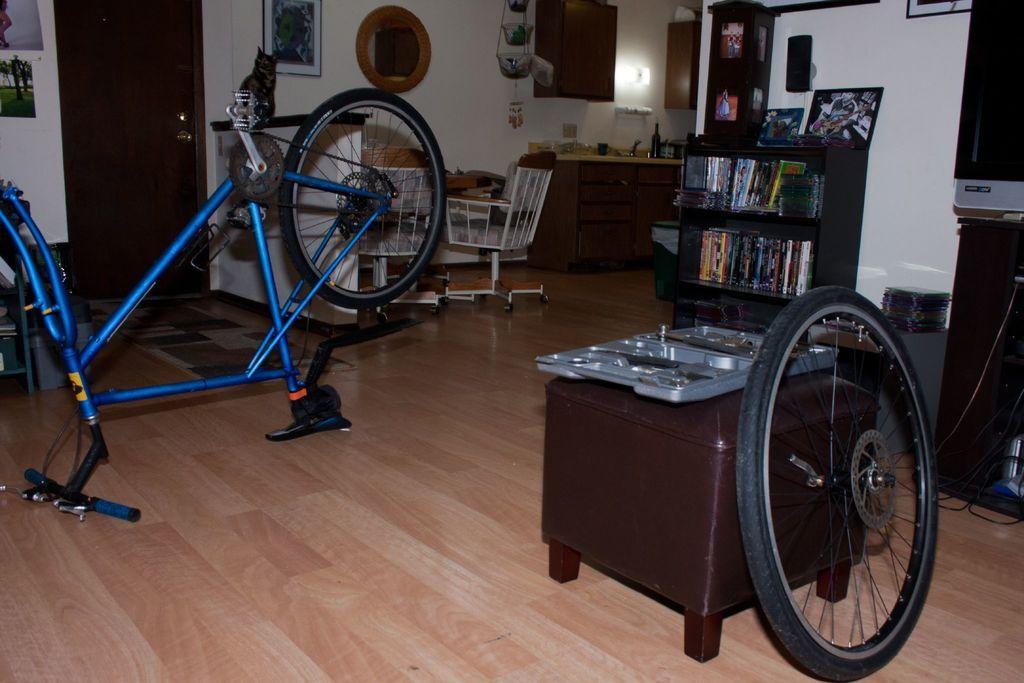Could you give a brief overview of what you see in this image? In this image I can see a bicycle which is blue in color on the floor, a brown colored couch, a wheel, a bookshelf with few books in it, a chair, a speaker, few photo frames, a white colored wall, a light, few cabinets, a television, few photo frames attached to the wall and the brown colored door. 